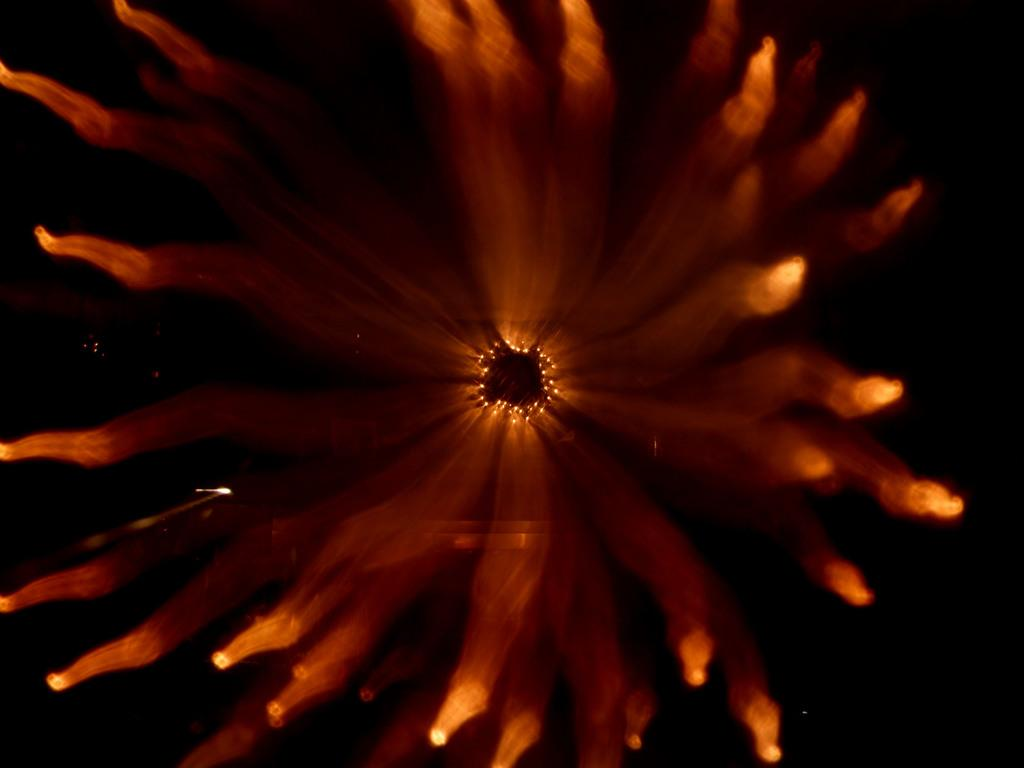What is the main subject of the image? There is a picture in the image. What does the picture resemble? The picture resembles a flower. What is the color of the background in the picture? The background of the picture is dark. How does the feeling of the flower change throughout the trail in the image? There is no trail or feeling associated with the flower in the image; it is a static picture of a flower with a dark background. 